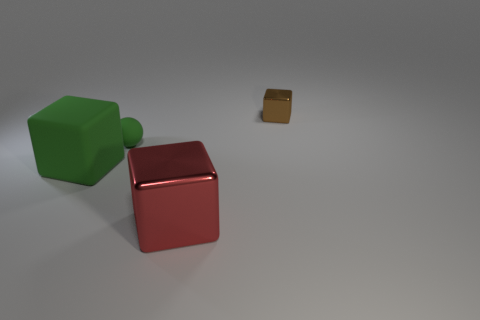Does the rubber ball have the same color as the big thing to the left of the small green matte ball?
Keep it short and to the point. Yes. Is the color of the matte sphere the same as the large metallic object?
Provide a succinct answer. No. How many other things are there of the same color as the ball?
Keep it short and to the point. 1. How many purple matte cylinders have the same size as the matte ball?
Provide a short and direct response. 0. Are there fewer large red things that are behind the green rubber ball than tiny blocks that are behind the big shiny block?
Provide a short and direct response. Yes. There is a cube that is left of the shiny thing that is in front of the tiny thing behind the green rubber sphere; what is its size?
Provide a short and direct response. Large. What is the size of the thing that is to the left of the brown block and right of the green rubber sphere?
Provide a short and direct response. Large. There is a small object that is left of the shiny thing that is in front of the brown metallic thing; what is its shape?
Offer a very short reply. Sphere. Are there any other things of the same color as the ball?
Provide a succinct answer. Yes. What is the shape of the metal object that is behind the big green matte thing?
Provide a succinct answer. Cube. 